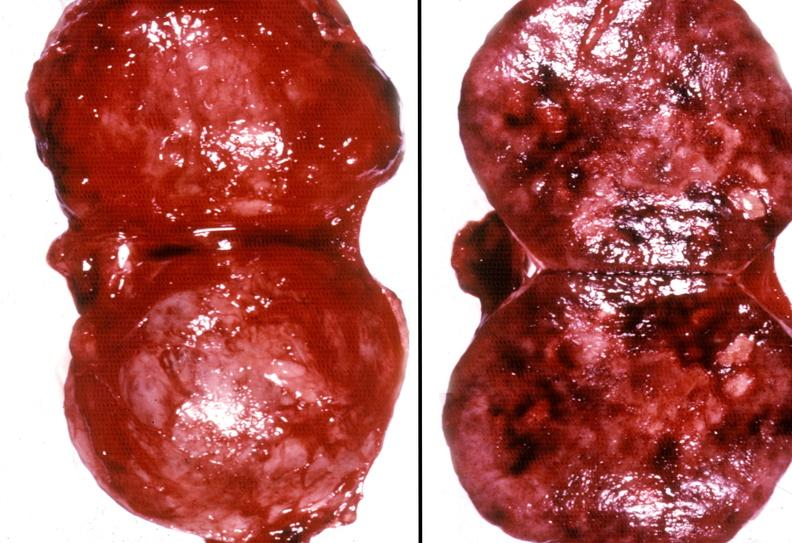what does this image show?
Answer the question using a single word or phrase. Adrenal phaeochromocytoma 